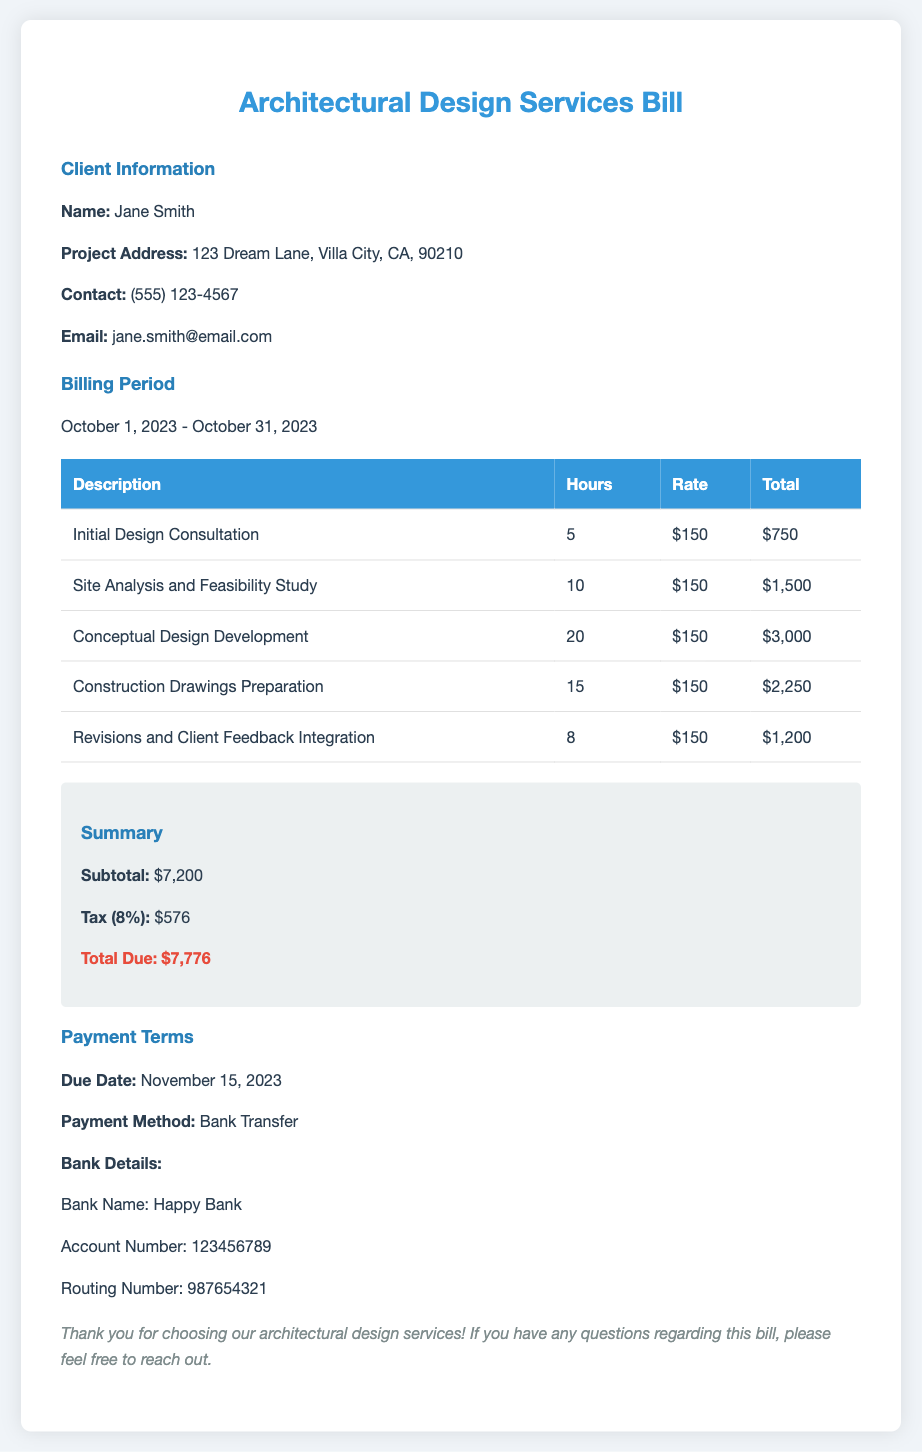What is the client's name? The client's name is specified in the client information section of the document.
Answer: Jane Smith What is the billing period? The billing period is mentioned in the corresponding section of the document.
Answer: October 1, 2023 - October 31, 2023 How much is the total due? The total due is calculated and summarized towards the end of the document.
Answer: $7,776 What is the tax percentage? The tax percentage is mentioned in the summary section of the document.
Answer: 8% What is the due date for payment? The due date is provided in the payment terms section of the document.
Answer: November 15, 2023 How many hours were spent on the Construction Drawings Preparation? The number of hours is indicated in the corresponding table entry.
Answer: 15 What is the hourly rate for the services? The hourly rate is consistent across various entries in the billing table.
Answer: $150 What is the subtotal before tax? The subtotal is explicitly stated in the summary section of the document.
Answer: $7,200 What payment method is specified? The payment method is detailed in the payment terms section of the document.
Answer: Bank Transfer 